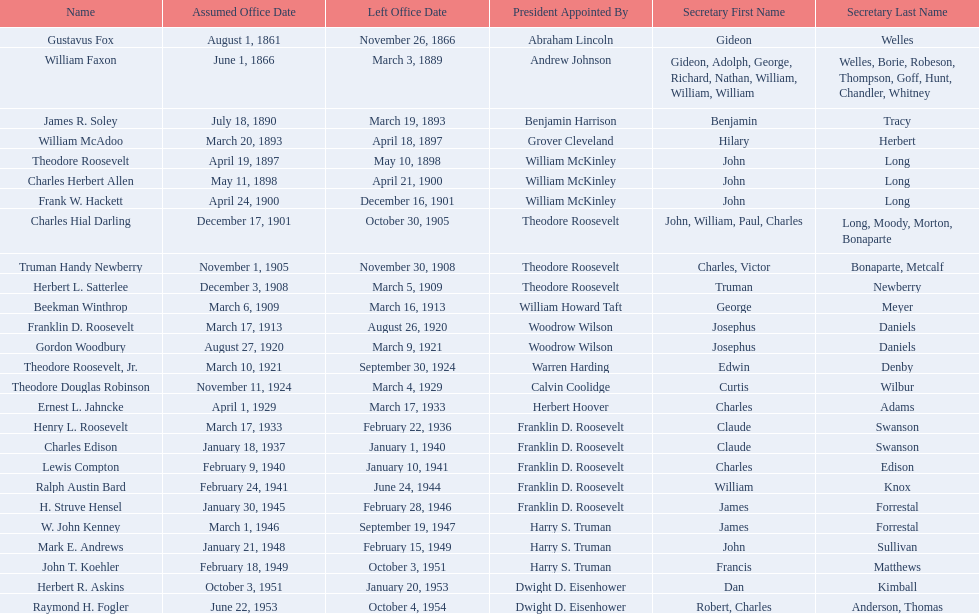What are all the names? Gustavus Fox, William Faxon, James R. Soley, William McAdoo, Theodore Roosevelt, Charles Herbert Allen, Frank W. Hackett, Charles Hial Darling, Truman Handy Newberry, Herbert L. Satterlee, Beekman Winthrop, Franklin D. Roosevelt, Gordon Woodbury, Theodore Roosevelt, Jr., Theodore Douglas Robinson, Ernest L. Jahncke, Henry L. Roosevelt, Charles Edison, Lewis Compton, Ralph Austin Bard, H. Struve Hensel, W. John Kenney, Mark E. Andrews, John T. Koehler, Herbert R. Askins, Raymond H. Fogler. When did they leave office? November 26, 1866, March 3, 1889, March 19, 1893, April 18, 1897, May 10, 1898, April 21, 1900, December 16, 1901, October 30, 1905, November 30, 1908, March 5, 1909, March 16, 1913, August 26, 1920, March 9, 1921, September 30, 1924, March 4, 1929, March 17, 1933, February 22, 1936, January 1, 1940, January 10, 1941, June 24, 1944, February 28, 1946, September 19, 1947, February 15, 1949, October 3, 1951, January 20, 1953, October 4, 1954. And when did raymond h. fogler leave? October 4, 1954. 